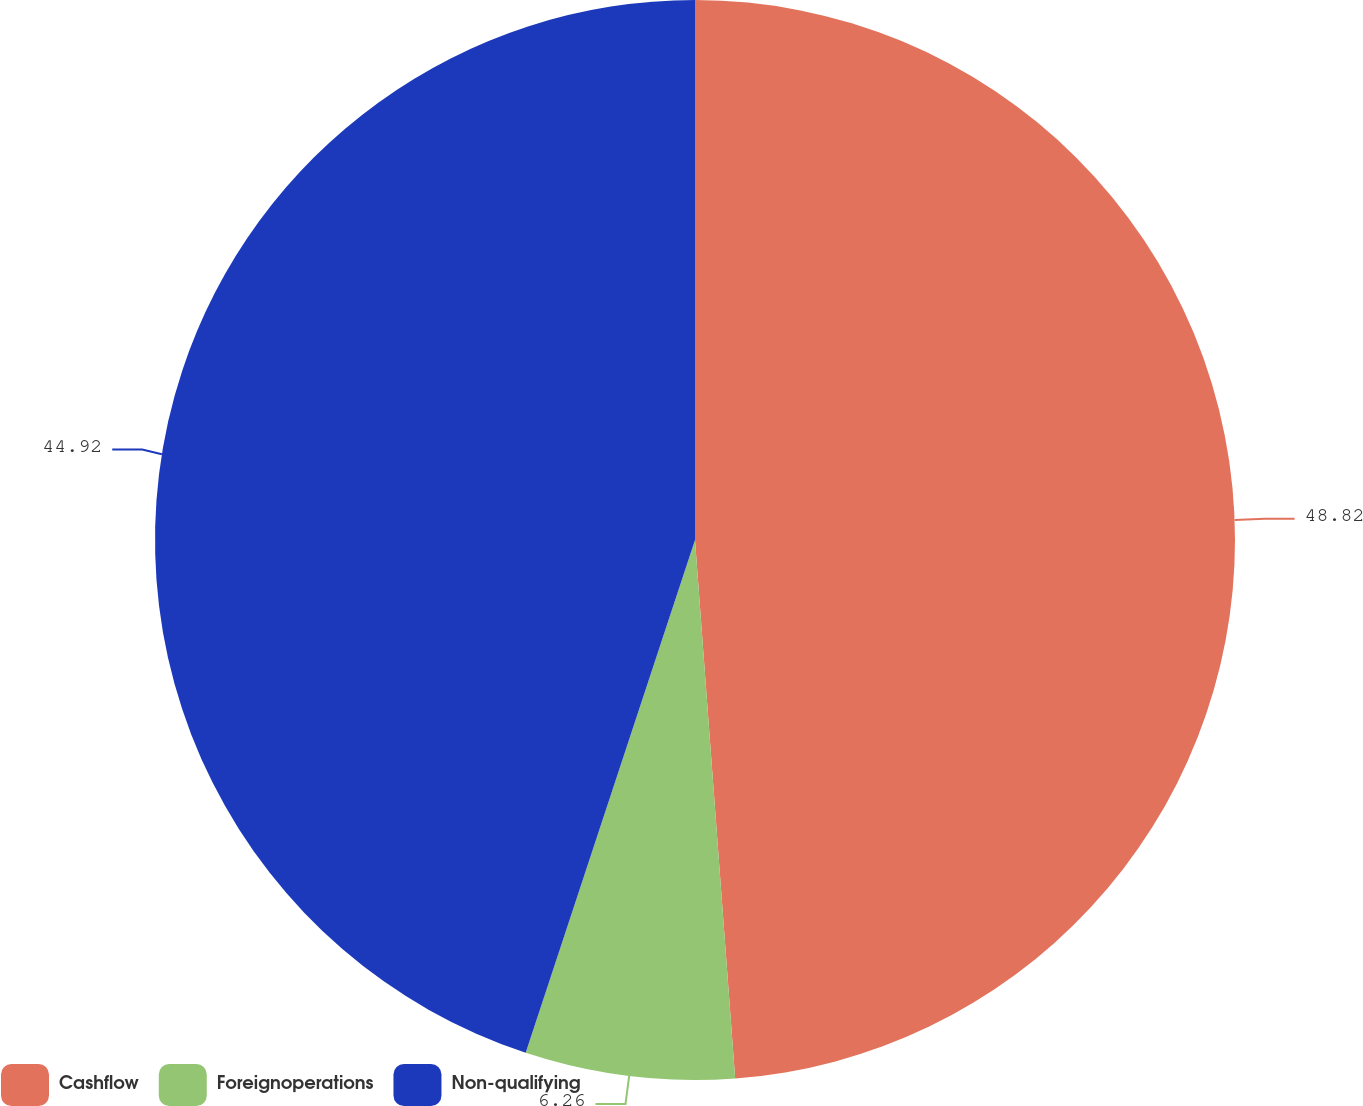Convert chart to OTSL. <chart><loc_0><loc_0><loc_500><loc_500><pie_chart><fcel>Cashflow<fcel>Foreignoperations<fcel>Non-qualifying<nl><fcel>48.81%<fcel>6.26%<fcel>44.92%<nl></chart> 